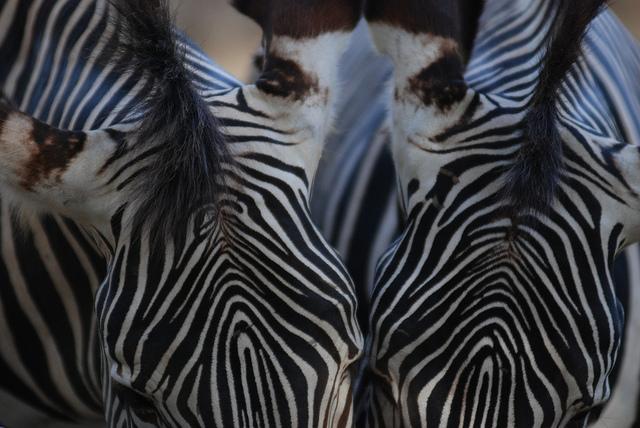What colors are the animal's stripes?
Short answer required. Black. What animal has this pattern?
Short answer required. Zebra. Is the full body of the animal in this picture?
Quick response, please. No. 